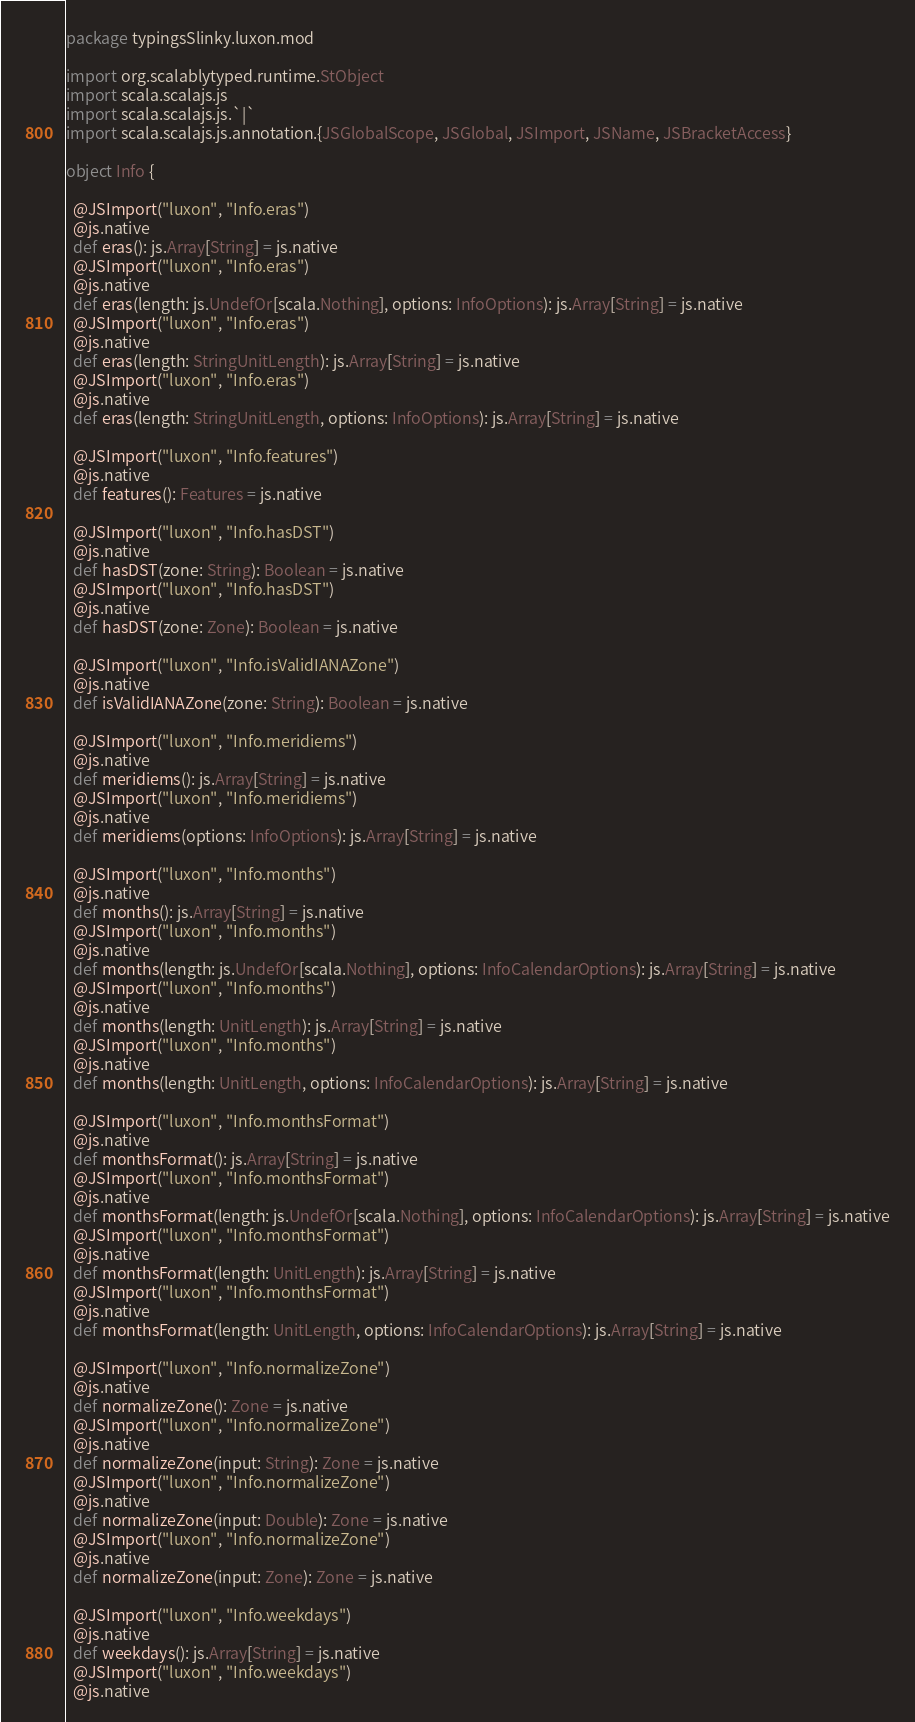Convert code to text. <code><loc_0><loc_0><loc_500><loc_500><_Scala_>package typingsSlinky.luxon.mod

import org.scalablytyped.runtime.StObject
import scala.scalajs.js
import scala.scalajs.js.`|`
import scala.scalajs.js.annotation.{JSGlobalScope, JSGlobal, JSImport, JSName, JSBracketAccess}

object Info {
  
  @JSImport("luxon", "Info.eras")
  @js.native
  def eras(): js.Array[String] = js.native
  @JSImport("luxon", "Info.eras")
  @js.native
  def eras(length: js.UndefOr[scala.Nothing], options: InfoOptions): js.Array[String] = js.native
  @JSImport("luxon", "Info.eras")
  @js.native
  def eras(length: StringUnitLength): js.Array[String] = js.native
  @JSImport("luxon", "Info.eras")
  @js.native
  def eras(length: StringUnitLength, options: InfoOptions): js.Array[String] = js.native
  
  @JSImport("luxon", "Info.features")
  @js.native
  def features(): Features = js.native
  
  @JSImport("luxon", "Info.hasDST")
  @js.native
  def hasDST(zone: String): Boolean = js.native
  @JSImport("luxon", "Info.hasDST")
  @js.native
  def hasDST(zone: Zone): Boolean = js.native
  
  @JSImport("luxon", "Info.isValidIANAZone")
  @js.native
  def isValidIANAZone(zone: String): Boolean = js.native
  
  @JSImport("luxon", "Info.meridiems")
  @js.native
  def meridiems(): js.Array[String] = js.native
  @JSImport("luxon", "Info.meridiems")
  @js.native
  def meridiems(options: InfoOptions): js.Array[String] = js.native
  
  @JSImport("luxon", "Info.months")
  @js.native
  def months(): js.Array[String] = js.native
  @JSImport("luxon", "Info.months")
  @js.native
  def months(length: js.UndefOr[scala.Nothing], options: InfoCalendarOptions): js.Array[String] = js.native
  @JSImport("luxon", "Info.months")
  @js.native
  def months(length: UnitLength): js.Array[String] = js.native
  @JSImport("luxon", "Info.months")
  @js.native
  def months(length: UnitLength, options: InfoCalendarOptions): js.Array[String] = js.native
  
  @JSImport("luxon", "Info.monthsFormat")
  @js.native
  def monthsFormat(): js.Array[String] = js.native
  @JSImport("luxon", "Info.monthsFormat")
  @js.native
  def monthsFormat(length: js.UndefOr[scala.Nothing], options: InfoCalendarOptions): js.Array[String] = js.native
  @JSImport("luxon", "Info.monthsFormat")
  @js.native
  def monthsFormat(length: UnitLength): js.Array[String] = js.native
  @JSImport("luxon", "Info.monthsFormat")
  @js.native
  def monthsFormat(length: UnitLength, options: InfoCalendarOptions): js.Array[String] = js.native
  
  @JSImport("luxon", "Info.normalizeZone")
  @js.native
  def normalizeZone(): Zone = js.native
  @JSImport("luxon", "Info.normalizeZone")
  @js.native
  def normalizeZone(input: String): Zone = js.native
  @JSImport("luxon", "Info.normalizeZone")
  @js.native
  def normalizeZone(input: Double): Zone = js.native
  @JSImport("luxon", "Info.normalizeZone")
  @js.native
  def normalizeZone(input: Zone): Zone = js.native
  
  @JSImport("luxon", "Info.weekdays")
  @js.native
  def weekdays(): js.Array[String] = js.native
  @JSImport("luxon", "Info.weekdays")
  @js.native</code> 